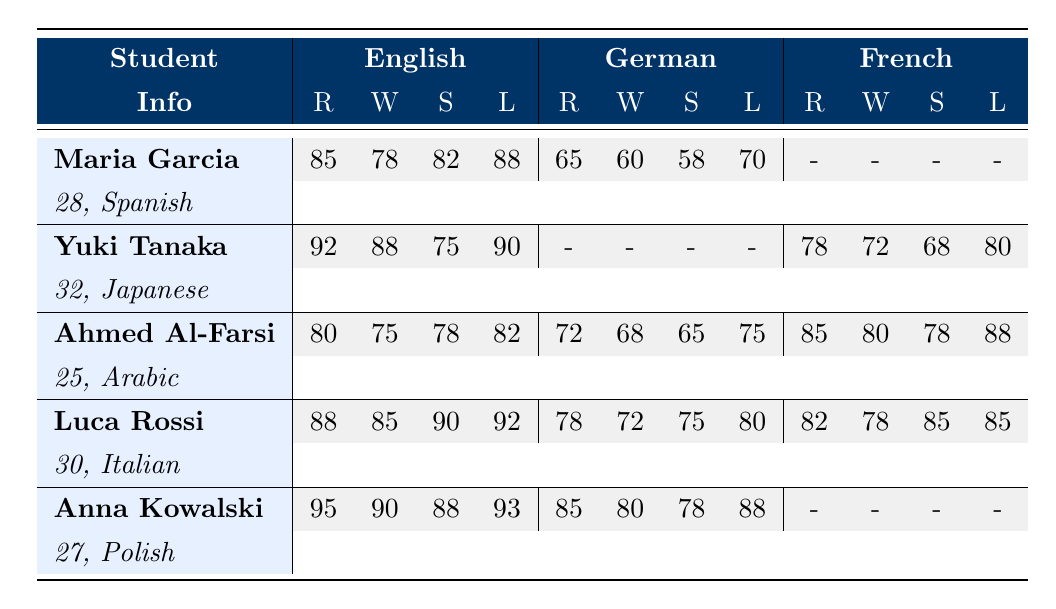What is the English writing score of Maria Garcia? Maria Garcia's English writing score is directly listed in the table. Looking under the English column, find the Writing (W) score for Maria Garcia, which is 78.
Answer: 78 What is the German reading score of Ahmed Al-Farsi? Ahmed Al-Farsi's German reading score is directly available in the table. Under the German column, the Reading (R) score for Ahmed Al-Farsi is 72.
Answer: 72 Which student has the highest English listening score? To find the highest English listening score, compare all the English Listening (L) scores in the table. The scores are 88 for Maria, 90 for Yuki, 82 for Ahmed, 92 for Luca, and 93 for Anna. The highest score is 93, belonging to Anna Kowalski.
Answer: Anna Kowalski Is there any student who has null scores in all French categories? Check the French columns for each student to see if any have null values in all categories (Reading, Writing, Speaking, Listening). Maria and Anna both have null scores, but Anna has no scores in French at all, making her the only one with all nulls in French.
Answer: Yes What is the average English speaking score for all students? First, gather all the English speaking scores: Maria (82), Yuki (75), Ahmed (78), Luca (90), and Anna (88). Then, sum them up: 82 + 75 + 78 + 90 + 88 = 413. Next, divide by the number of students (5): 413 / 5 = 82.6.
Answer: 82.6 How does Luca Rossi's German speaking score compare to Anna Kowalski's German writing score? Luca Rossi's German speaking score is 75. Anna Kowalski's German writing score is 80. Now, compare these two scores: 75 (Luca) is less than 80 (Anna), showing that Luca scored lower.
Answer: Luca scored lower Which native language has the lowest scores in German listening among the students? Review the German listening scores for each student: Maria (70), Yuki (null), Ahmed (75), Luca (80), and Anna (88). The lowest score in German listening is 70, which belongs to Maria, who speaks Spanish.
Answer: Spanish In which subject did Yuki Tanaka demonstrate the highest performance? Examine Yuki Tanaka's scores across different subjects. The scores are English (Reading 92), German (all nulls), and French (Reading 78). The highest score is 92 in English Reading.
Answer: English Reading What is the total score of Anna Kowalski across all subjects except French? Sum up all of Anna Kowalski's scores excluding French. The scores are: English (95 + 90 + 88 + 93) = 366 and German (85 + 80 + 78 + 88) = 331. Total = 366 + 331 = 697.
Answer: 697 Identify the student with the highest score in French writing. Check the French Writing (W) scores for all students: Maria has null, Yuki has 72, Ahmed has 80, Luca has 78, and Anna has null. The highest score is 80, belonging to Ahmed Al-Farsi.
Answer: Ahmed Al-Farsi 